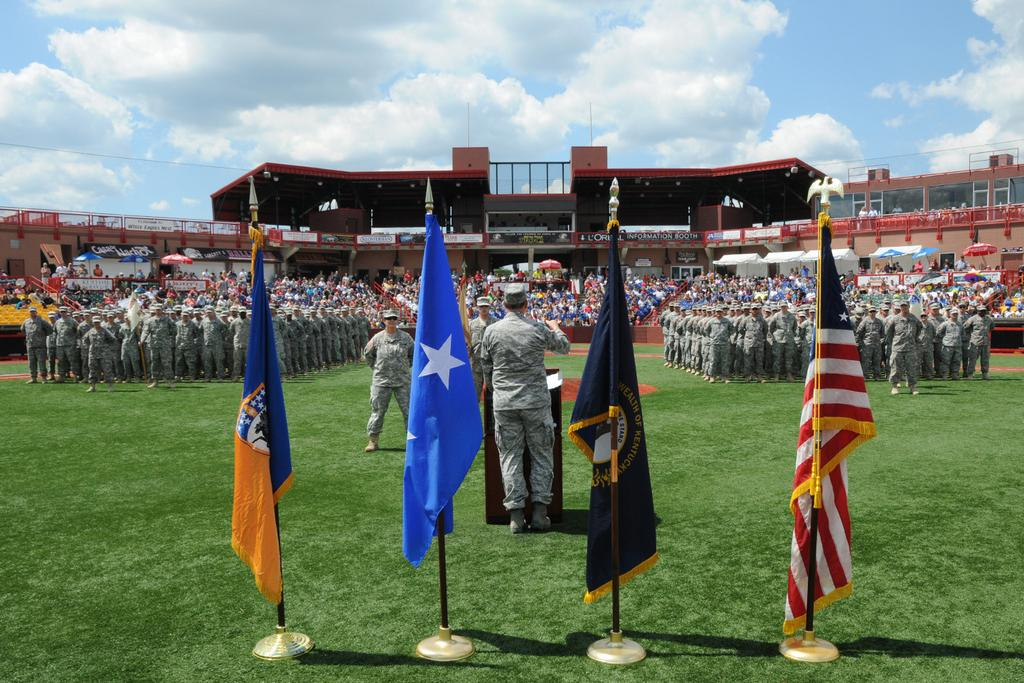What objects are at the top of the poles in the image? There are flags at the poles in the image. What are the people wearing in the image? The people are wearing uniforms in the image. Where are the people standing in the image? The people are standing on the ground in the image. What type of structure is visible in the image? There is a stadium visible in the image. What are the people in the stadium doing? People are sitting in the stadium in the image. Can you see the arm of the astronaut in the image? There is no astronaut or arm present in the image. What type of flight is taking place in the image? There is no flight present in the image; it features people standing near poles with flags and a stadium in the background. 